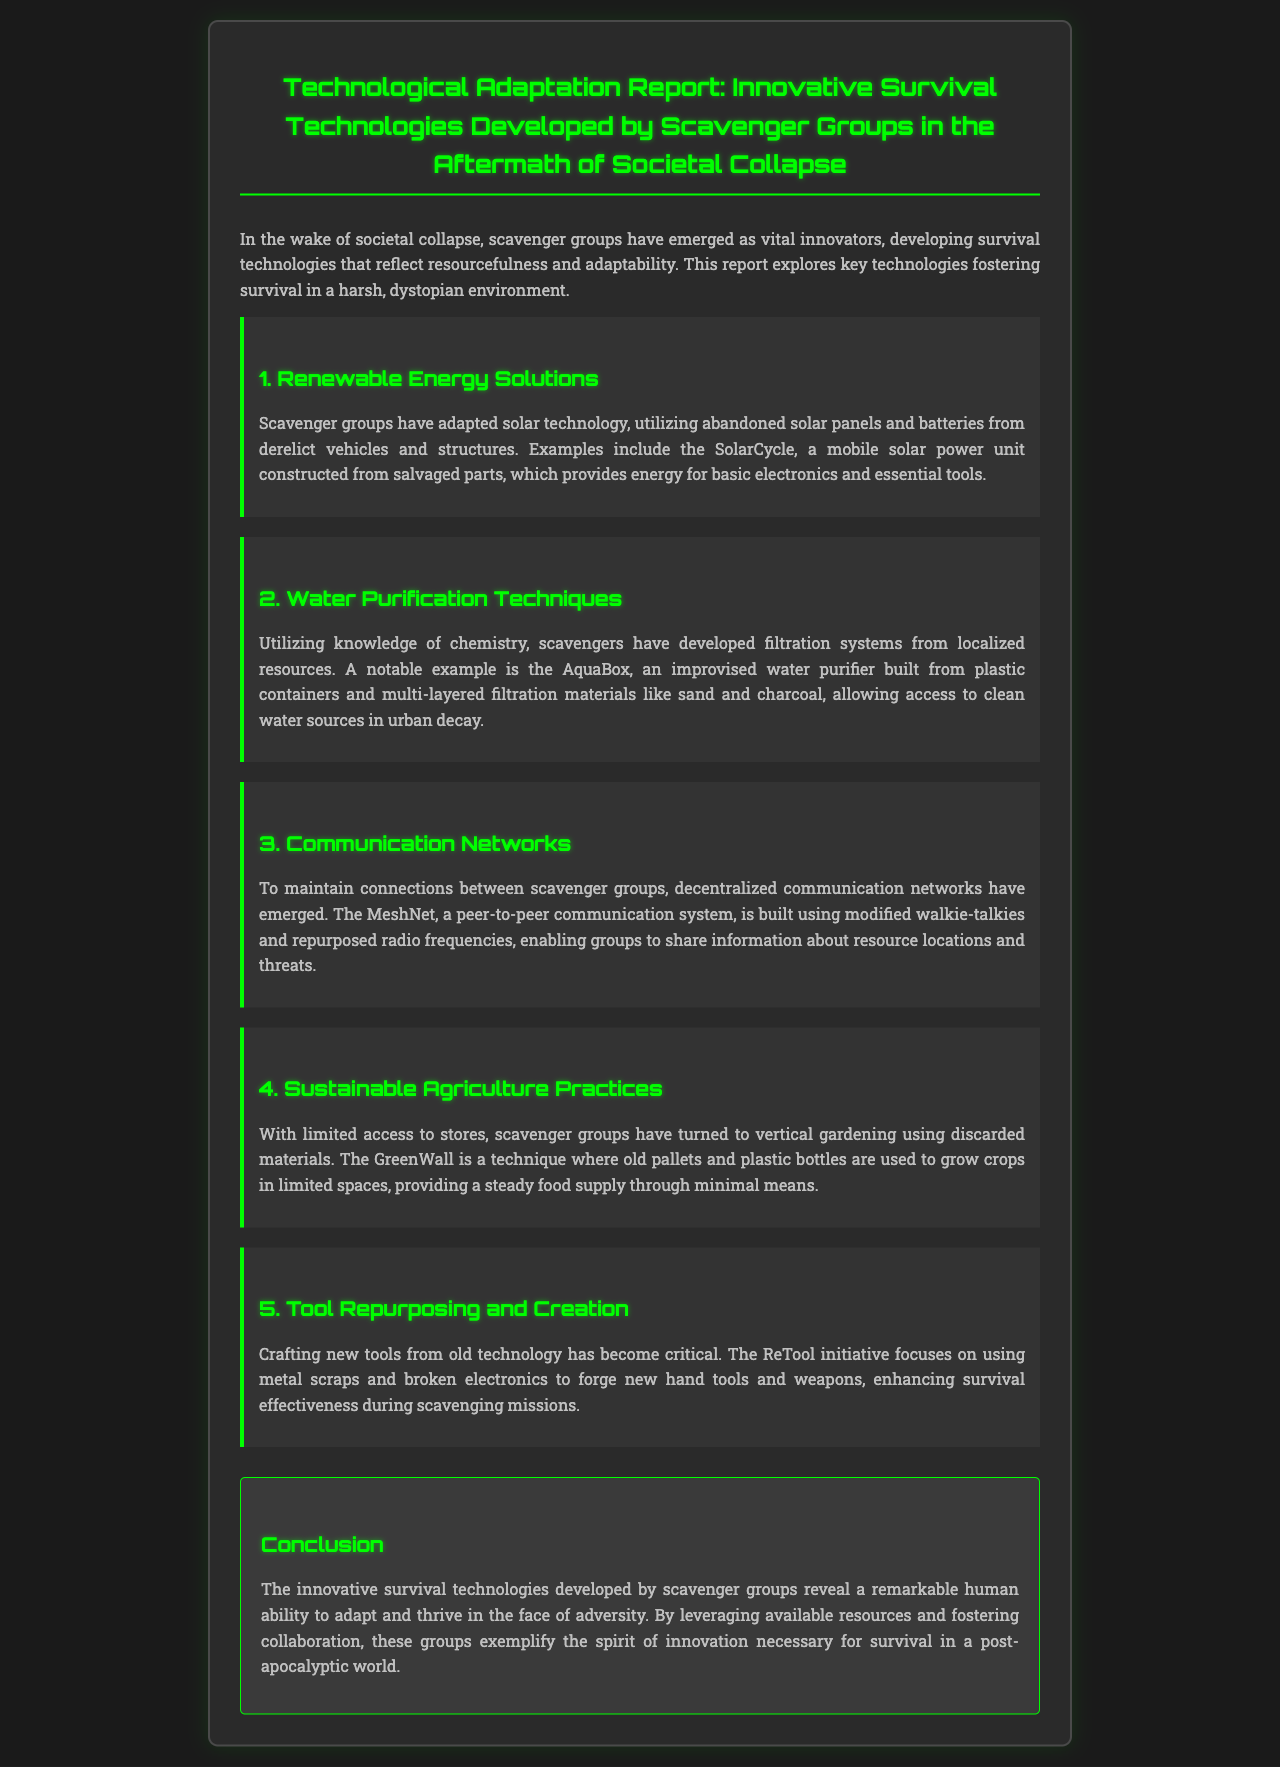What is the title of the report? The title of the report is the main heading that summarizes its content, which is highlighted at the beginning of the document.
Answer: Technological Adaptation Report: Innovative Survival Technologies Developed by Scavenger Groups in the Aftermath of Societal Collapse What is the name of the mobile solar power unit? The mobile solar power unit is specifically mentioned as an example of renewable energy technology developed by scavenger groups in the report.
Answer: SolarCycle What does the AquaBox provide? The AquaBox is an improvised water purifier that enables scavenger groups to access a critical resource in their environment.
Answer: Clean water What is the primary function of MeshNet? The primary function of MeshNet establishes communication between scavenger groups, which is necessary for survival in a collapsing society.
Answer: Communication What sustainable practice is used to grow crops? The report discusses a specific sustainable agriculture technique that reflects innovation through limited resources available post-collapse.
Answer: Vertical gardening How do scavenger groups enhance survival effectiveness? The document explains a particular initiative that focuses on repurposing materials into essential items for survival amidst scarcity.
Answer: ReTool initiative What type of networks have emerged among scavenger groups? This type of network is described as decentralized and is essential for the communication of vital information in a post-apocalyptic context.
Answer: Communication networks How is the GreenWall constructed? The description in the document details the materials used to create this innovative agricultural solution for food supply.
Answer: Old pallets and plastic bottles What do the scavenger groups exemplify through their innovations? The conclusion of the report reflects on the broader implications of the adaptations made by scavenger groups in the face of societal collapse.
Answer: Spirit of innovation 